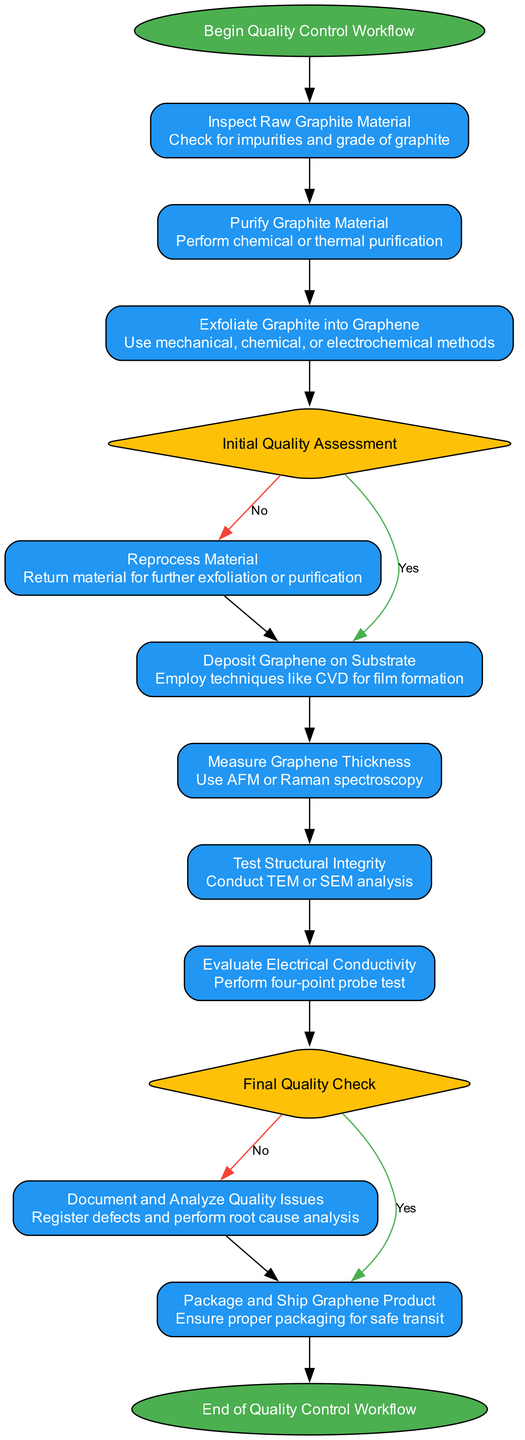What is the first step in the workflow? The first node in the workflow is labeled "Begin Quality Control Workflow," which indicates the start of the process.
Answer: Begin Quality Control Workflow How many decision nodes are in the workflow? The flowchart contains two decision nodes: "Initial Quality Assessment" and "Final Quality Check."
Answer: 2 What action is taken during the "Exfoliation Process"? The "Exfoliation Process" node specifies that graphene is created using mechanical, chemical, or electrochemical methods, capturing the purpose of this stage.
Answer: Use mechanical, chemical, or electrochemical methods If the graphene does not meet preliminary quality criteria, what is the next step? The node follows the "Initial Quality Assessment" decision and leads to the "Reprocess Material" action if the answer to the preliminary assessment is "no."
Answer: Reprocess Material What is the final action before the end of the workflow? The last action preceding the "End of Quality Control Workflow" is "Package and Ship Graphene Product," representing the final steps of quality control leading to delivery.
Answer: Package and Ship Graphene Product In what part of the workflow is electrical conductivity tested? The "Evaluate Electrical Conductivity" process is positioned after the "Measure Graphene Thickness" and before the "Final Quality Check." This shows where the electrical properties are verified.
Answer: Evaluate Electrical Conductivity What happens if the final quality check fails? If the "Final Quality Check" indicates failure, the workflow directs the process to "Document and Analyze Quality Issues" for addressing defects encountered during assessments.
Answer: Document and Analyze Quality Issues How are impurities verified during the quality control process? Impurities in the raw material are checked in the "Inspect Raw Graphite Material," ensuring that the initial input meets necessary standards.
Answer: Inspect Raw Graphite Material Which method is used for measuring graphene thickness? The diagram states that "Use AFM or Raman spectroscopy" is the method indicated for the measurement of the graphene's thickness in the corresponding process.
Answer: Use AFM or Raman spectroscopy 